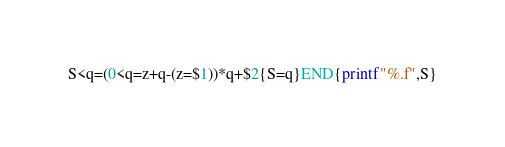Convert code to text. <code><loc_0><loc_0><loc_500><loc_500><_Awk_>S<q=(0<q=z+q-(z=$1))*q+$2{S=q}END{printf"%.f",S}</code> 